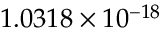Convert formula to latex. <formula><loc_0><loc_0><loc_500><loc_500>1 . 0 3 1 8 \times 1 0 ^ { - 1 8 }</formula> 